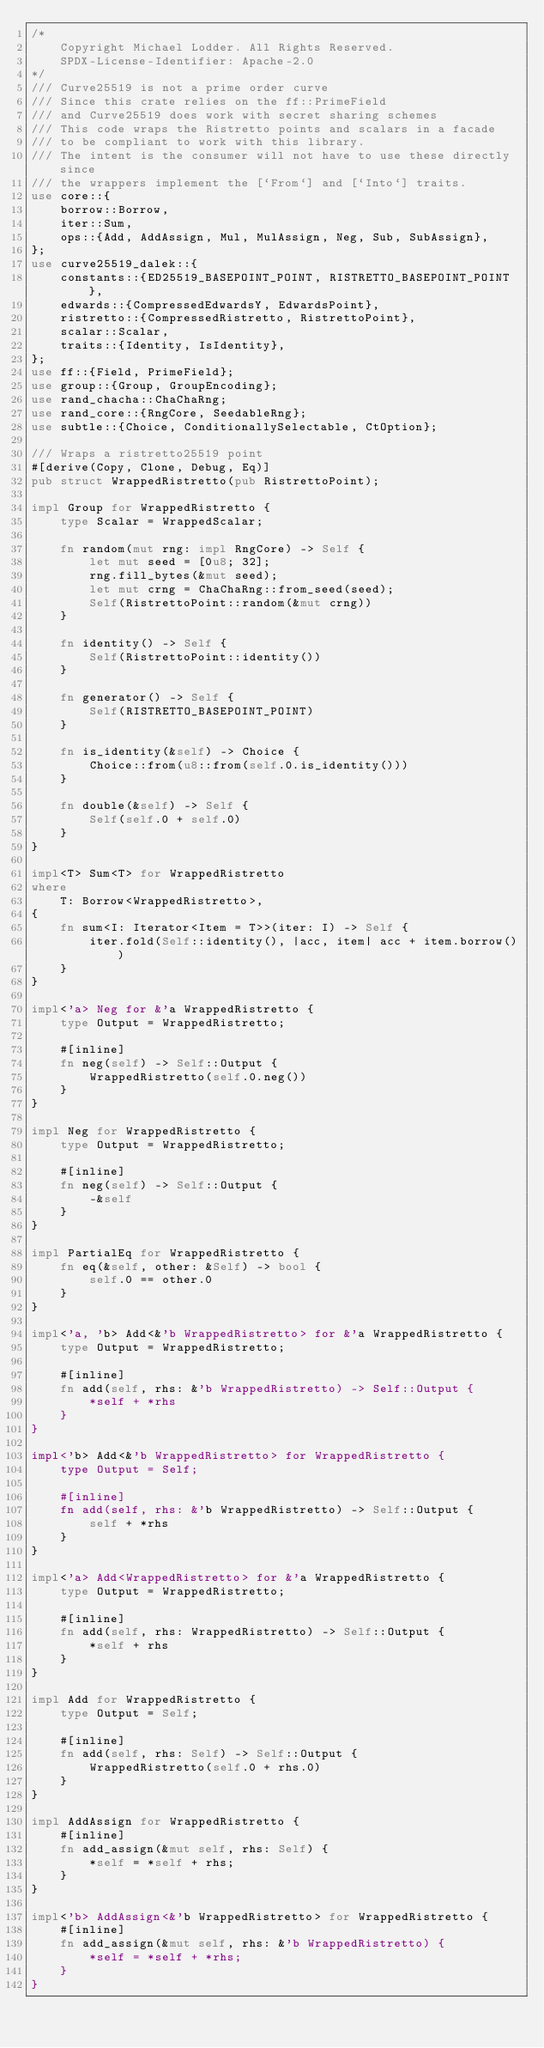Convert code to text. <code><loc_0><loc_0><loc_500><loc_500><_Rust_>/*
    Copyright Michael Lodder. All Rights Reserved.
    SPDX-License-Identifier: Apache-2.0
*/
/// Curve25519 is not a prime order curve
/// Since this crate relies on the ff::PrimeField
/// and Curve25519 does work with secret sharing schemes
/// This code wraps the Ristretto points and scalars in a facade
/// to be compliant to work with this library.
/// The intent is the consumer will not have to use these directly since
/// the wrappers implement the [`From`] and [`Into`] traits.
use core::{
    borrow::Borrow,
    iter::Sum,
    ops::{Add, AddAssign, Mul, MulAssign, Neg, Sub, SubAssign},
};
use curve25519_dalek::{
    constants::{ED25519_BASEPOINT_POINT, RISTRETTO_BASEPOINT_POINT},
    edwards::{CompressedEdwardsY, EdwardsPoint},
    ristretto::{CompressedRistretto, RistrettoPoint},
    scalar::Scalar,
    traits::{Identity, IsIdentity},
};
use ff::{Field, PrimeField};
use group::{Group, GroupEncoding};
use rand_chacha::ChaChaRng;
use rand_core::{RngCore, SeedableRng};
use subtle::{Choice, ConditionallySelectable, CtOption};

/// Wraps a ristretto25519 point
#[derive(Copy, Clone, Debug, Eq)]
pub struct WrappedRistretto(pub RistrettoPoint);

impl Group for WrappedRistretto {
    type Scalar = WrappedScalar;

    fn random(mut rng: impl RngCore) -> Self {
        let mut seed = [0u8; 32];
        rng.fill_bytes(&mut seed);
        let mut crng = ChaChaRng::from_seed(seed);
        Self(RistrettoPoint::random(&mut crng))
    }

    fn identity() -> Self {
        Self(RistrettoPoint::identity())
    }

    fn generator() -> Self {
        Self(RISTRETTO_BASEPOINT_POINT)
    }

    fn is_identity(&self) -> Choice {
        Choice::from(u8::from(self.0.is_identity()))
    }

    fn double(&self) -> Self {
        Self(self.0 + self.0)
    }
}

impl<T> Sum<T> for WrappedRistretto
where
    T: Borrow<WrappedRistretto>,
{
    fn sum<I: Iterator<Item = T>>(iter: I) -> Self {
        iter.fold(Self::identity(), |acc, item| acc + item.borrow())
    }
}

impl<'a> Neg for &'a WrappedRistretto {
    type Output = WrappedRistretto;

    #[inline]
    fn neg(self) -> Self::Output {
        WrappedRistretto(self.0.neg())
    }
}

impl Neg for WrappedRistretto {
    type Output = WrappedRistretto;

    #[inline]
    fn neg(self) -> Self::Output {
        -&self
    }
}

impl PartialEq for WrappedRistretto {
    fn eq(&self, other: &Self) -> bool {
        self.0 == other.0
    }
}

impl<'a, 'b> Add<&'b WrappedRistretto> for &'a WrappedRistretto {
    type Output = WrappedRistretto;

    #[inline]
    fn add(self, rhs: &'b WrappedRistretto) -> Self::Output {
        *self + *rhs
    }
}

impl<'b> Add<&'b WrappedRistretto> for WrappedRistretto {
    type Output = Self;

    #[inline]
    fn add(self, rhs: &'b WrappedRistretto) -> Self::Output {
        self + *rhs
    }
}

impl<'a> Add<WrappedRistretto> for &'a WrappedRistretto {
    type Output = WrappedRistretto;

    #[inline]
    fn add(self, rhs: WrappedRistretto) -> Self::Output {
        *self + rhs
    }
}

impl Add for WrappedRistretto {
    type Output = Self;

    #[inline]
    fn add(self, rhs: Self) -> Self::Output {
        WrappedRistretto(self.0 + rhs.0)
    }
}

impl AddAssign for WrappedRistretto {
    #[inline]
    fn add_assign(&mut self, rhs: Self) {
        *self = *self + rhs;
    }
}

impl<'b> AddAssign<&'b WrappedRistretto> for WrappedRistretto {
    #[inline]
    fn add_assign(&mut self, rhs: &'b WrappedRistretto) {
        *self = *self + *rhs;
    }
}
</code> 